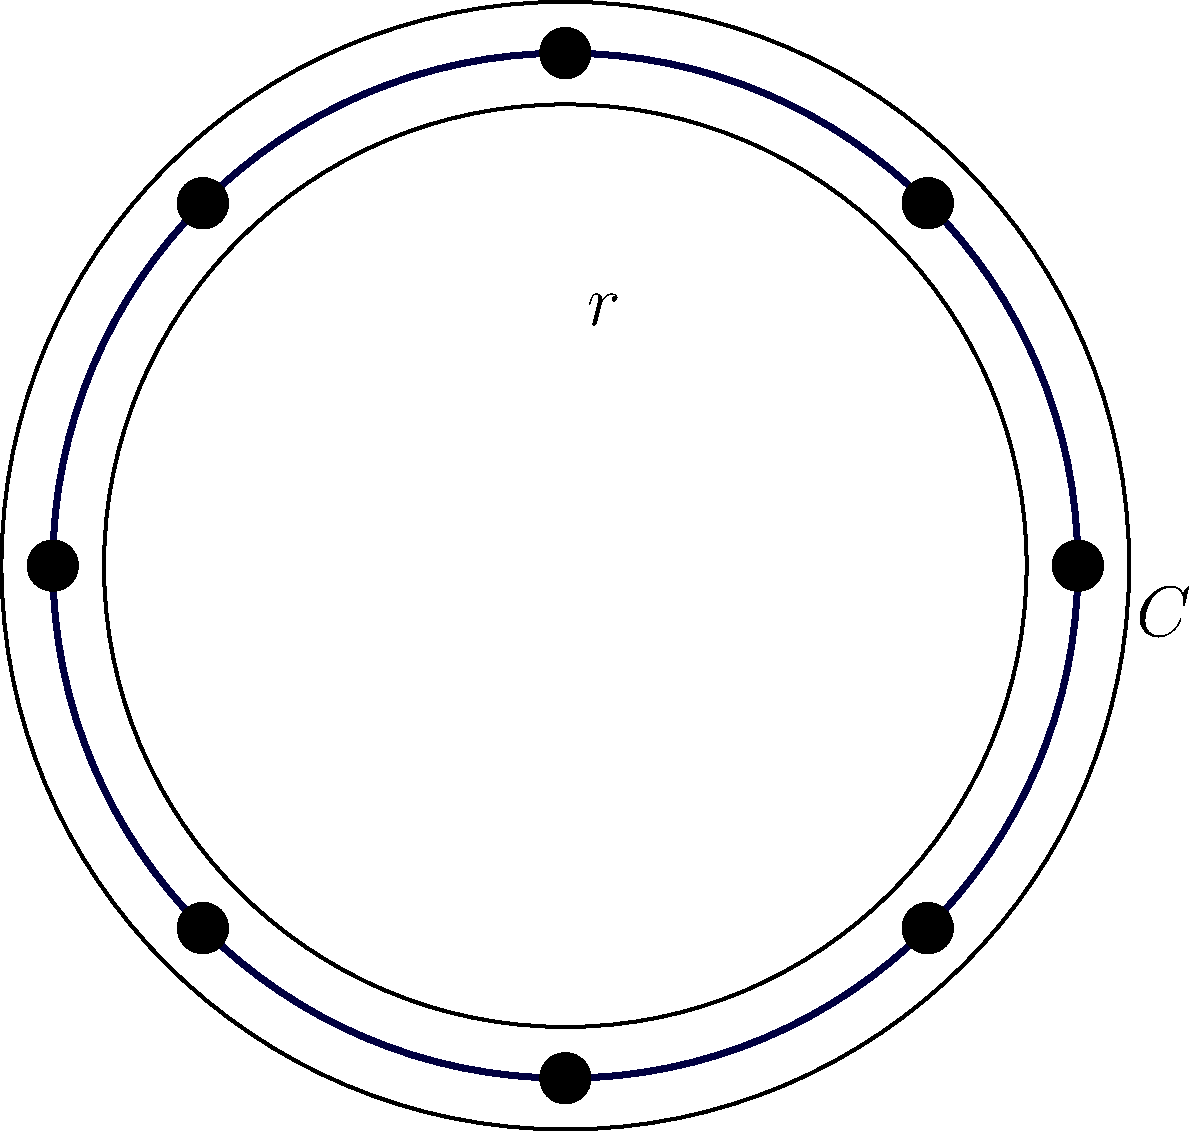In the circular musical staff above, eight equally spaced notes are placed along the circumference. If the radius of the staff is $r$ units, express the circumference $C$ in terms of $r$ and $\pi$. How does this relate to the concept of pitch class sets in ethnomusicology? To solve this problem, we'll follow these steps:

1. Recall the formula for the circumference of a circle:
   $$C = 2\pi r$$
   where $C$ is the circumference and $r$ is the radius.

2. In this case, we're given the radius $r$, so we can directly apply the formula:
   $$C = 2\pi r$$

3. This formula gives us the circumference in terms of $r$ and $\pi$, as requested.

4. Relating this to ethnomusicology and pitch class sets:
   - The circular representation is similar to the pitch class clock used in music theory.
   - In a pitch class set, there are 12 distinct pitch classes (in 12-tone equal temperament), corresponding to the 12 semitones in an octave.
   - The circular staff in the image has 8 notes, which could represent an octatonic scale or a subset of a pitch class set.
   - Just as the circumference formula $C = 2\pi r$ shows how the circle's size relates to its radius, pitch class set theory demonstrates how different musical intervals relate to each other within the cyclical structure of an octave.
   - This circular representation is particularly relevant in ethnomusicology when studying non-Western tuning systems or scales that may not conform to the standard 12-tone equal temperament.
Answer: $C = 2\pi r$ 